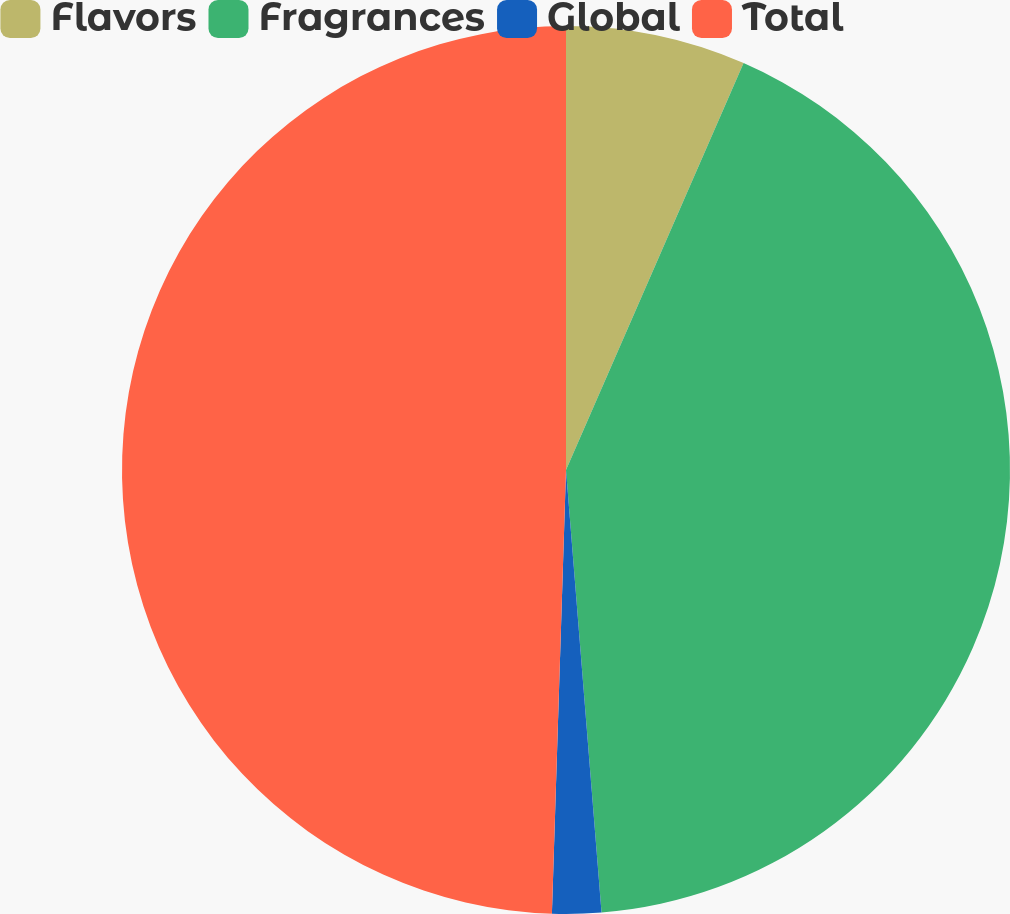Convert chart to OTSL. <chart><loc_0><loc_0><loc_500><loc_500><pie_chart><fcel>Flavors<fcel>Fragrances<fcel>Global<fcel>Total<nl><fcel>6.55%<fcel>42.18%<fcel>1.78%<fcel>49.5%<nl></chart> 